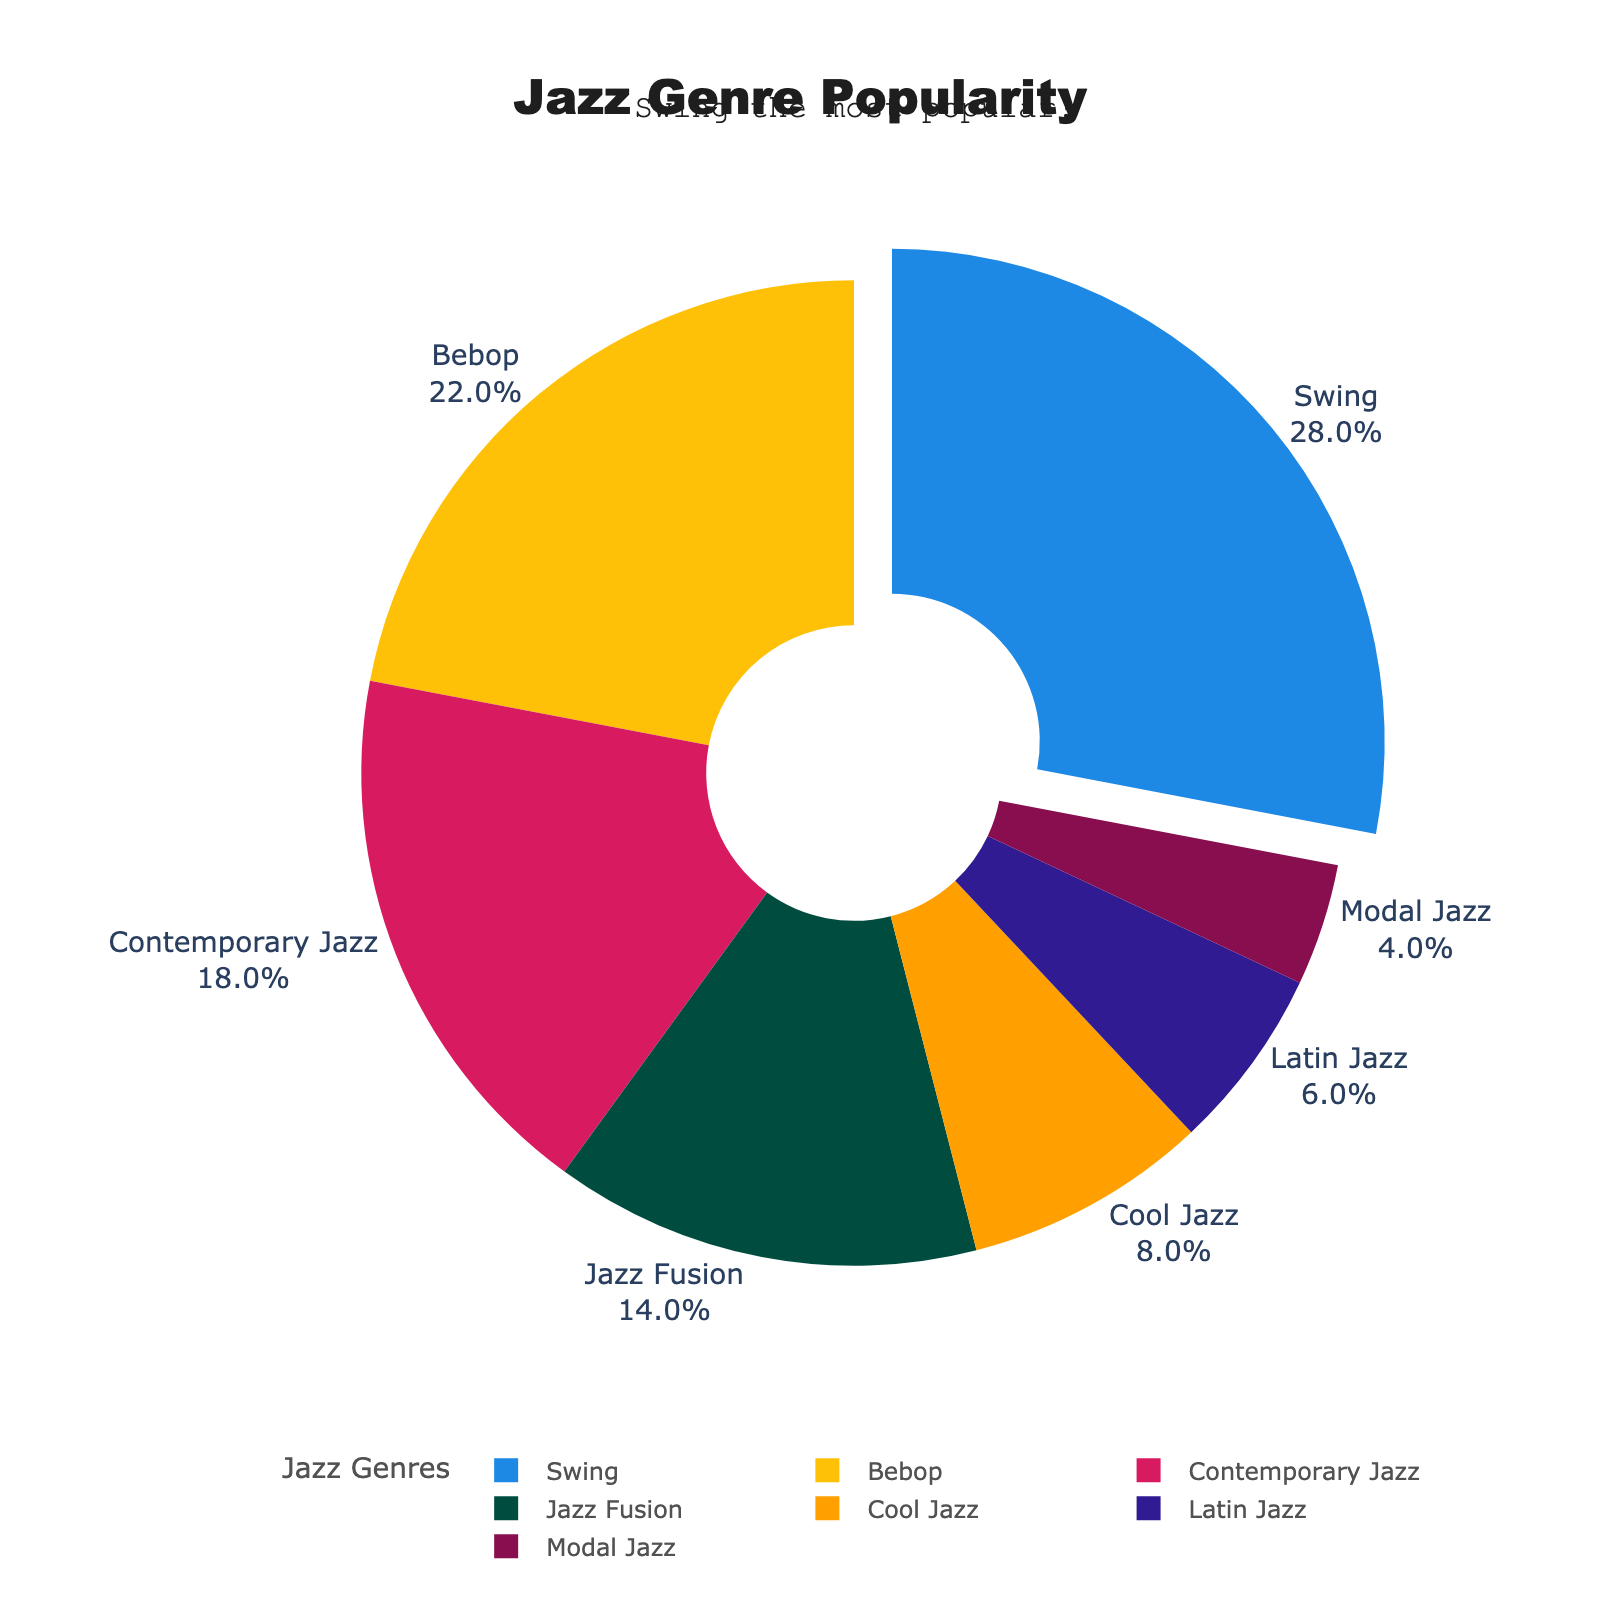Who has the highest popularity among jazz genres? The figure highlights that Swing has the highest popularity, indicated by both the largest segment and a visual pull-out effect emphasizing its value.
Answer: Swing Which jazz genres are more popular than Contemporary Jazz? The percentages for Swing (28%) and Bebop (22%) are both higher than Contemporary Jazz (18%), making them more popular.
Answer: Swing, Bebop What combined percentage do the less popular genres (below Contemporary Jazz) make up? Adding the percentages for Jazz Fusion (14%), Cool Jazz (8%), Latin Jazz (6%), and Modal Jazz (4%) results in: 14 + 8 + 6 + 4 = 32%.
Answer: 32% Is the sum of Swing and Bebop's popularity greater than half of the overall distribution? Adding Swing (28%) and Bebop (22%) results in 28 + 22 = 50%, which is exactly half of the total distribution.
Answer: No What is the visual difference in segment sizes between Swing and Jazz Fusion? Comparing the figures, Swing's segment takes up more visual space (28%) than Jazz Fusion's (14%), exactly twice as much.
Answer: Swing's segment is twice as large as Jazz Fusion's Does Contemporary Jazz's segment have more visual prominence than Cool Jazz? Contemporary Jazz (18%) occupies more space on the pie chart and has a larger segment than Cool Jazz (8%).
Answer: Yes How does Latin Jazz compare in popularity to the average of Bebop and Swing? The average of Bebop (22%) and Swing (28%) is (22 + 28) / 2 = 25%. Latin Jazz has 6%, which is much lower than the average of 25%.
Answer: Much lower What percentage of the total distribution is made up by Bebop and Jazz Fusion? Adding Bebop (22%) and Jazz Fusion (14%) results in 22 + 14 = 36%.
Answer: 36% Which genre has the smallest slice in the pie chart? The segment for Modal Jazz is the smallest, with a percentage of 4%.
Answer: Modal Jazz 